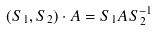<formula> <loc_0><loc_0><loc_500><loc_500>( S _ { 1 } , S _ { 2 } ) \cdot A = S _ { 1 } A S _ { 2 } ^ { - 1 }</formula> 